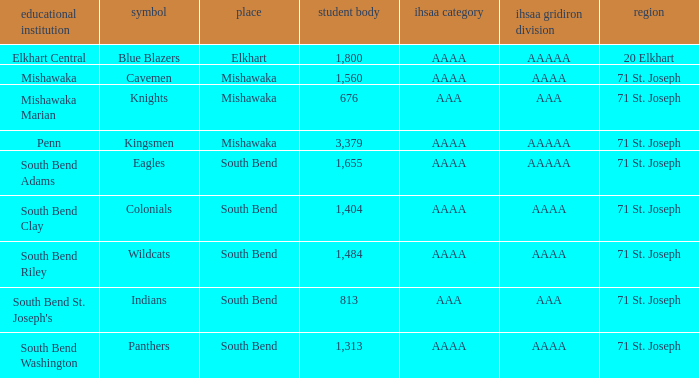What location has an enrollment greater than 1,313, and kingsmen as the mascot? Mishawaka. 